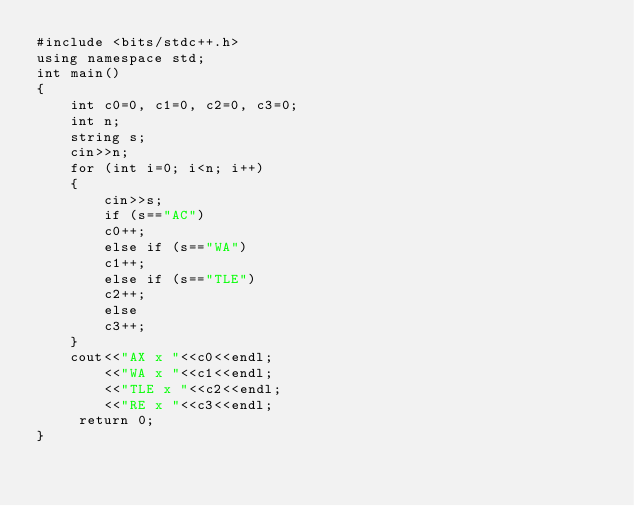Convert code to text. <code><loc_0><loc_0><loc_500><loc_500><_C_>#include <bits/stdc++.h>
using namespace std;
int main()
{
	int c0=0, c1=0, c2=0, c3=0;
	int n;
	string s;
	cin>>n;
	for (int i=0; i<n; i++)
	{
		cin>>s;
		if (s=="AC")
		c0++;
		else if (s=="WA")
		c1++;
		else if (s=="TLE")
		c2++;
		else 
		c3++;
    }
	cout<<"AX x "<<c0<<endl;
		<<"WA x "<<c1<<endl;
		<<"TLE x "<<c2<<endl;
		<<"RE x "<<c3<<endl;
	 return 0;
}</code> 